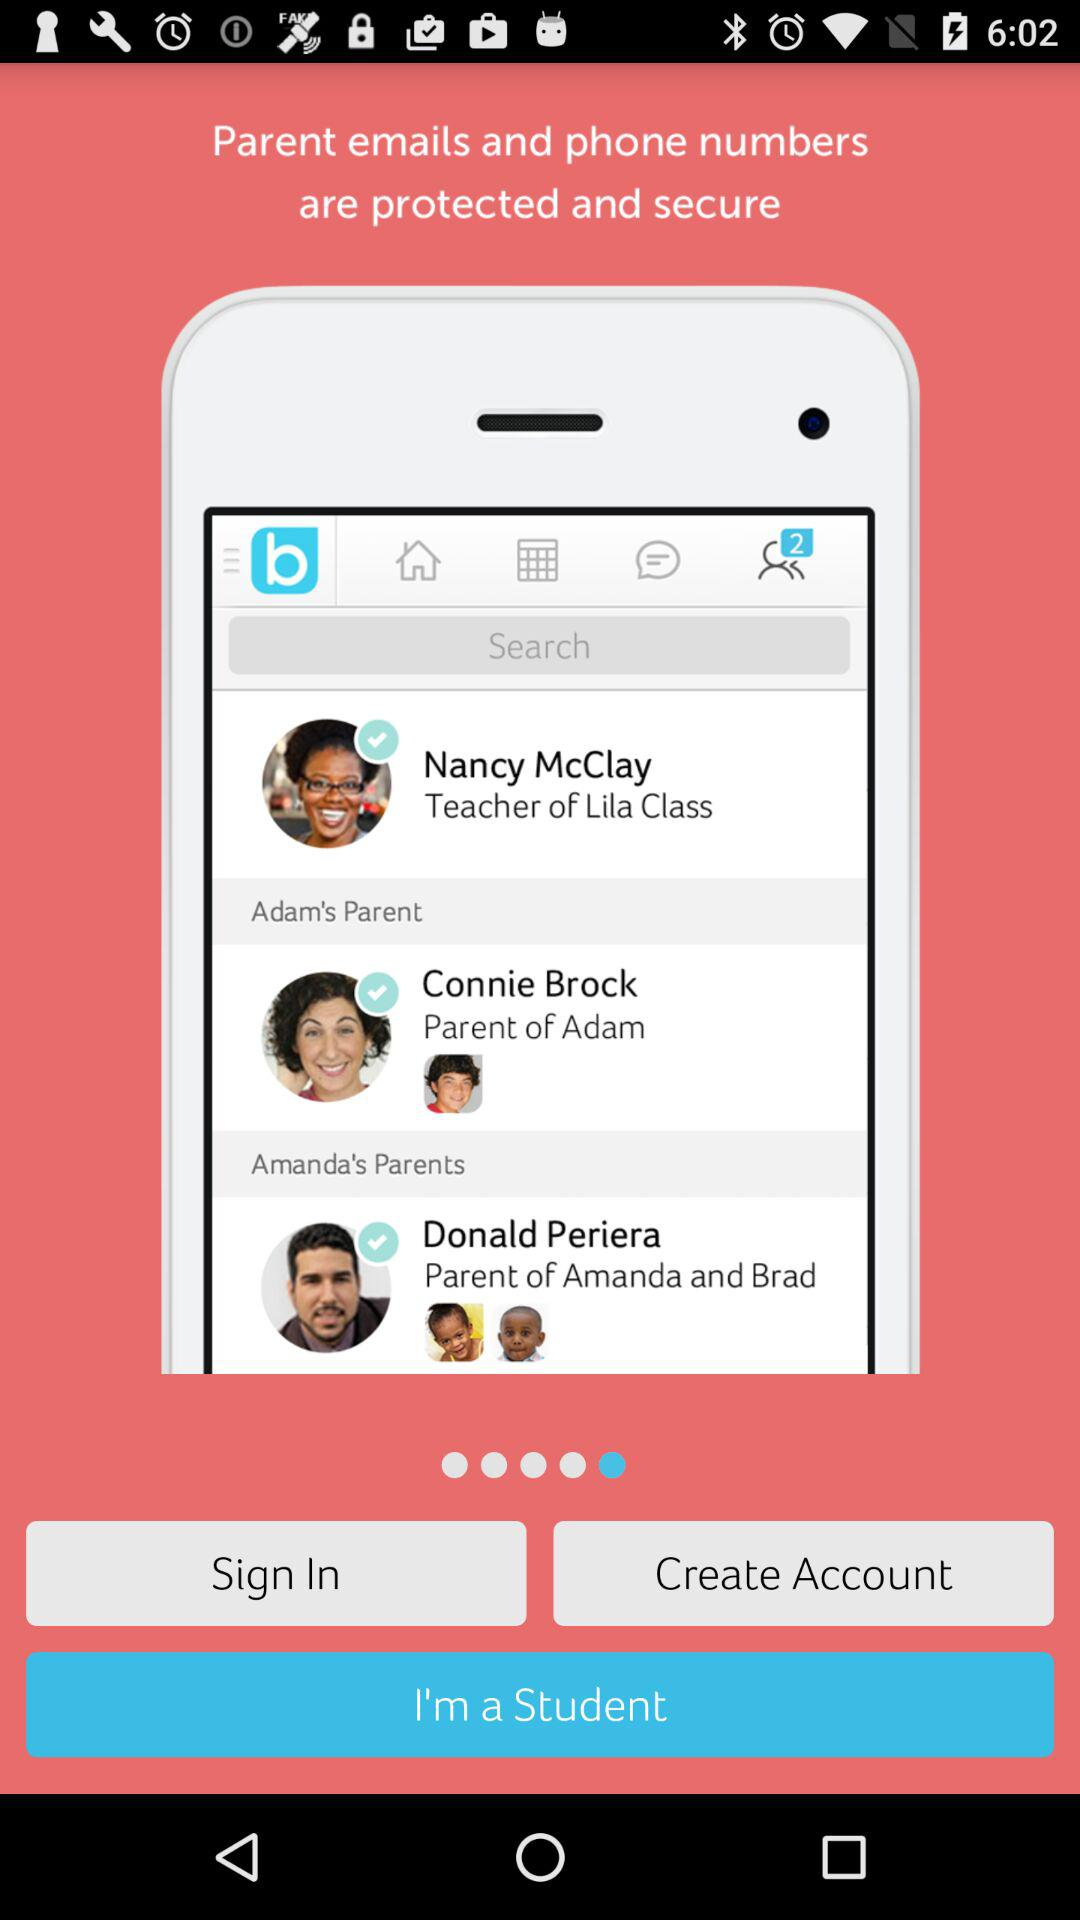Who is the parent of Amanda and Brad? The parent of Amanda and Brad is Donald Periera. 